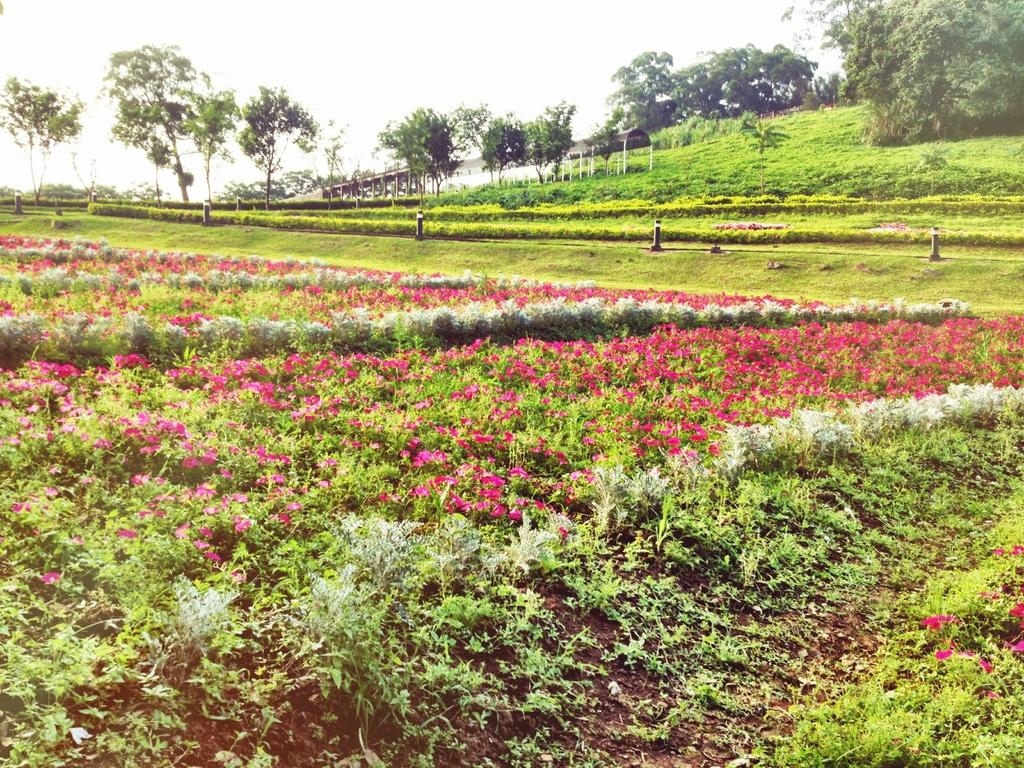What type of vegetation can be seen in the image? There are plants, flowers, grass, and trees in the image. What structures are present in the image? There are poles and sheds in the image. What can be seen in the background of the image? The sky is visible in the background of the image. What type of beast can be seen guiding the tongue in the image? There is no beast, tongue, or any guiding activity present in the image. 